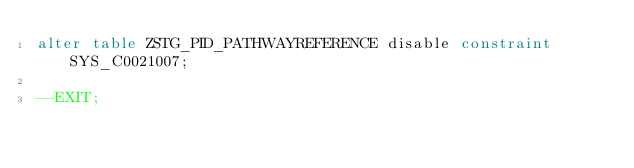<code> <loc_0><loc_0><loc_500><loc_500><_SQL_>alter table ZSTG_PID_PATHWAYREFERENCE disable constraint SYS_C0021007;

--EXIT;
</code> 